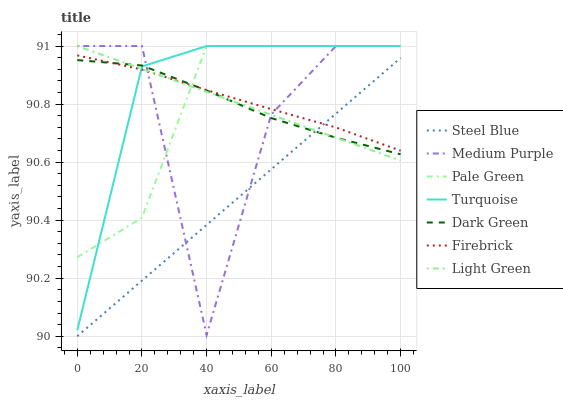Does Firebrick have the minimum area under the curve?
Answer yes or no. No. Does Firebrick have the maximum area under the curve?
Answer yes or no. No. Is Firebrick the smoothest?
Answer yes or no. No. Is Firebrick the roughest?
Answer yes or no. No. Does Firebrick have the lowest value?
Answer yes or no. No. Does Firebrick have the highest value?
Answer yes or no. No. Is Steel Blue less than Pale Green?
Answer yes or no. Yes. Is Turquoise greater than Steel Blue?
Answer yes or no. Yes. Does Steel Blue intersect Pale Green?
Answer yes or no. No. 